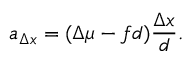<formula> <loc_0><loc_0><loc_500><loc_500>a _ { \Delta x } = ( \Delta \mu - f d ) \frac { \Delta x } { d } .</formula> 